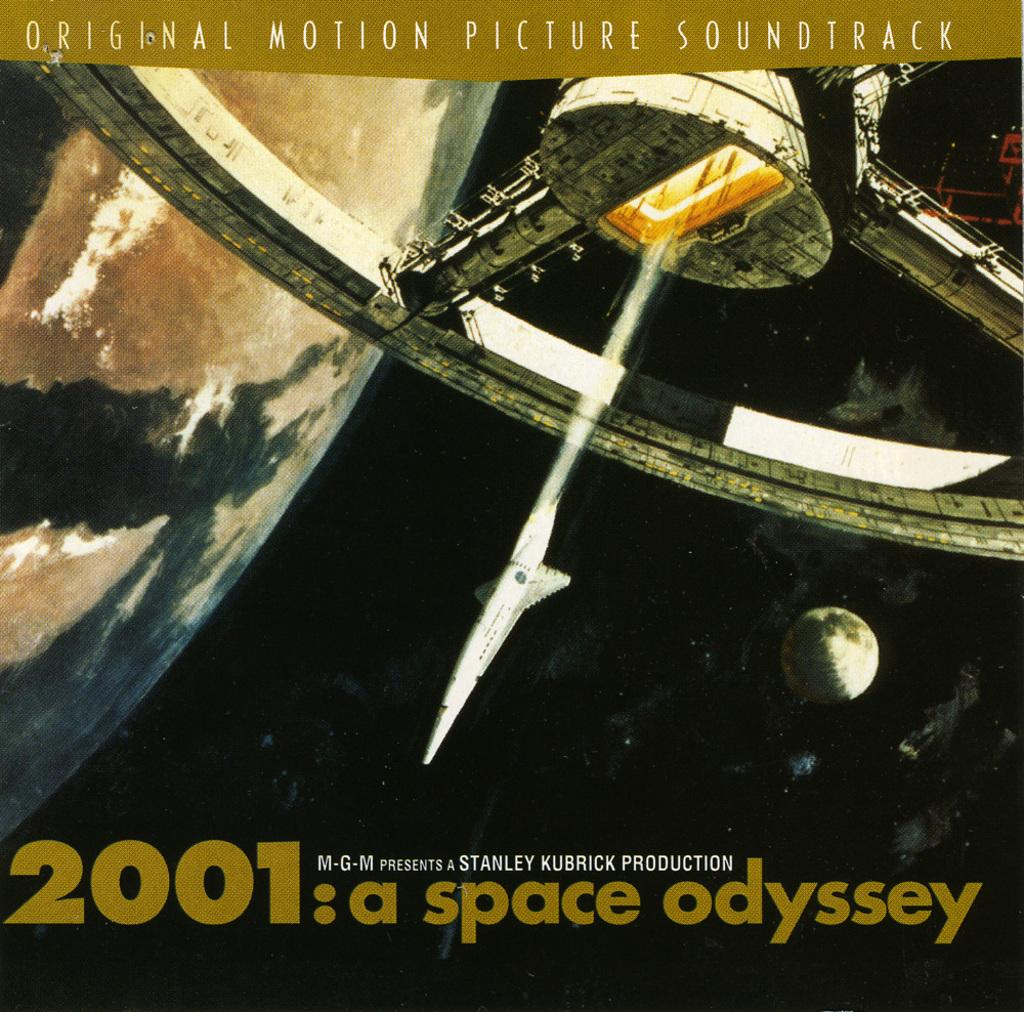What can be found at the top of the image? There is text at the top of the image. What can be found at the bottom of the image? There is text at the bottom of the image. What object resembling a planet is on the left side of the image? There is an object resembling the Earth on the left side of the image. What object resembling a machine is at the top of the image? There is an object resembling a machine at the top of the image. How do we know that the image has been edited? The fact that the image has been edited is mentioned. Can you see a bee flying near the Earth in the image? No, there is no bee present in the image. Is there a swing visible in the image? No, there is no swing present in the image. 